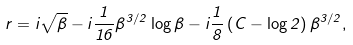<formula> <loc_0><loc_0><loc_500><loc_500>\ r = i \sqrt { \beta } - i \frac { 1 } { 1 6 } \beta ^ { 3 / 2 } \log \beta - i \frac { 1 } { 8 } \left ( C - \log 2 \right ) \beta ^ { 3 / 2 } ,</formula> 